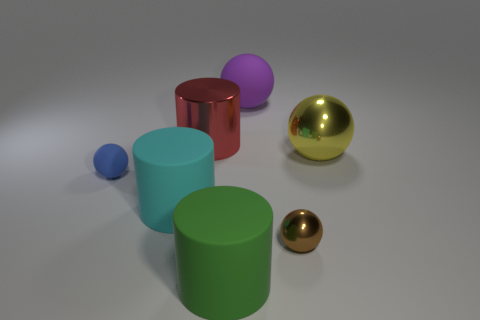Add 3 large yellow metallic cylinders. How many objects exist? 10 Subtract all cylinders. How many objects are left? 4 Add 1 tiny blue balls. How many tiny blue balls are left? 2 Add 3 big purple balls. How many big purple balls exist? 4 Subtract 1 purple spheres. How many objects are left? 6 Subtract all purple rubber balls. Subtract all rubber spheres. How many objects are left? 4 